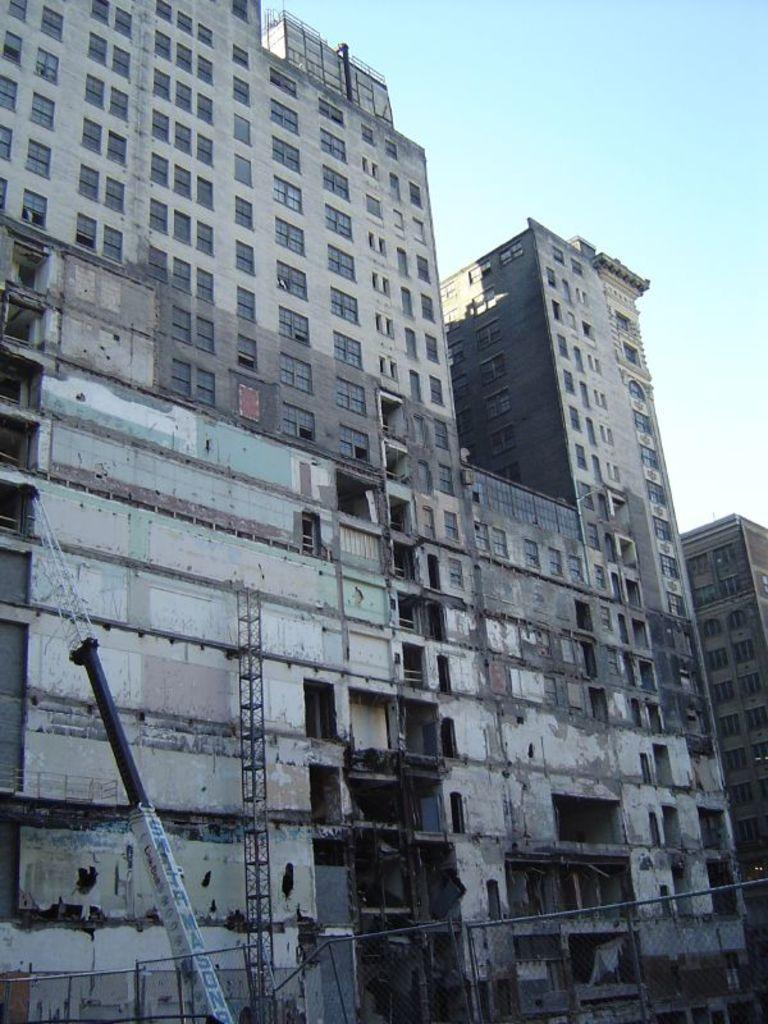What type of structures can be seen in the image? There are buildings in the image. Can you identify any specific architectural features? Yes, there is a pillar in the image. What else can be seen in the image related to construction? There is a crane hand in the image. What is visible at the top of the image? The sky is visible at the top of the image. How many spiders are crawling on the buildings in the image? There are no spiders visible in the image; it features buildings, a pillar, and a crane hand. What type of stocking is being used by the expert in the image? There is no expert or stocking present in the image. 